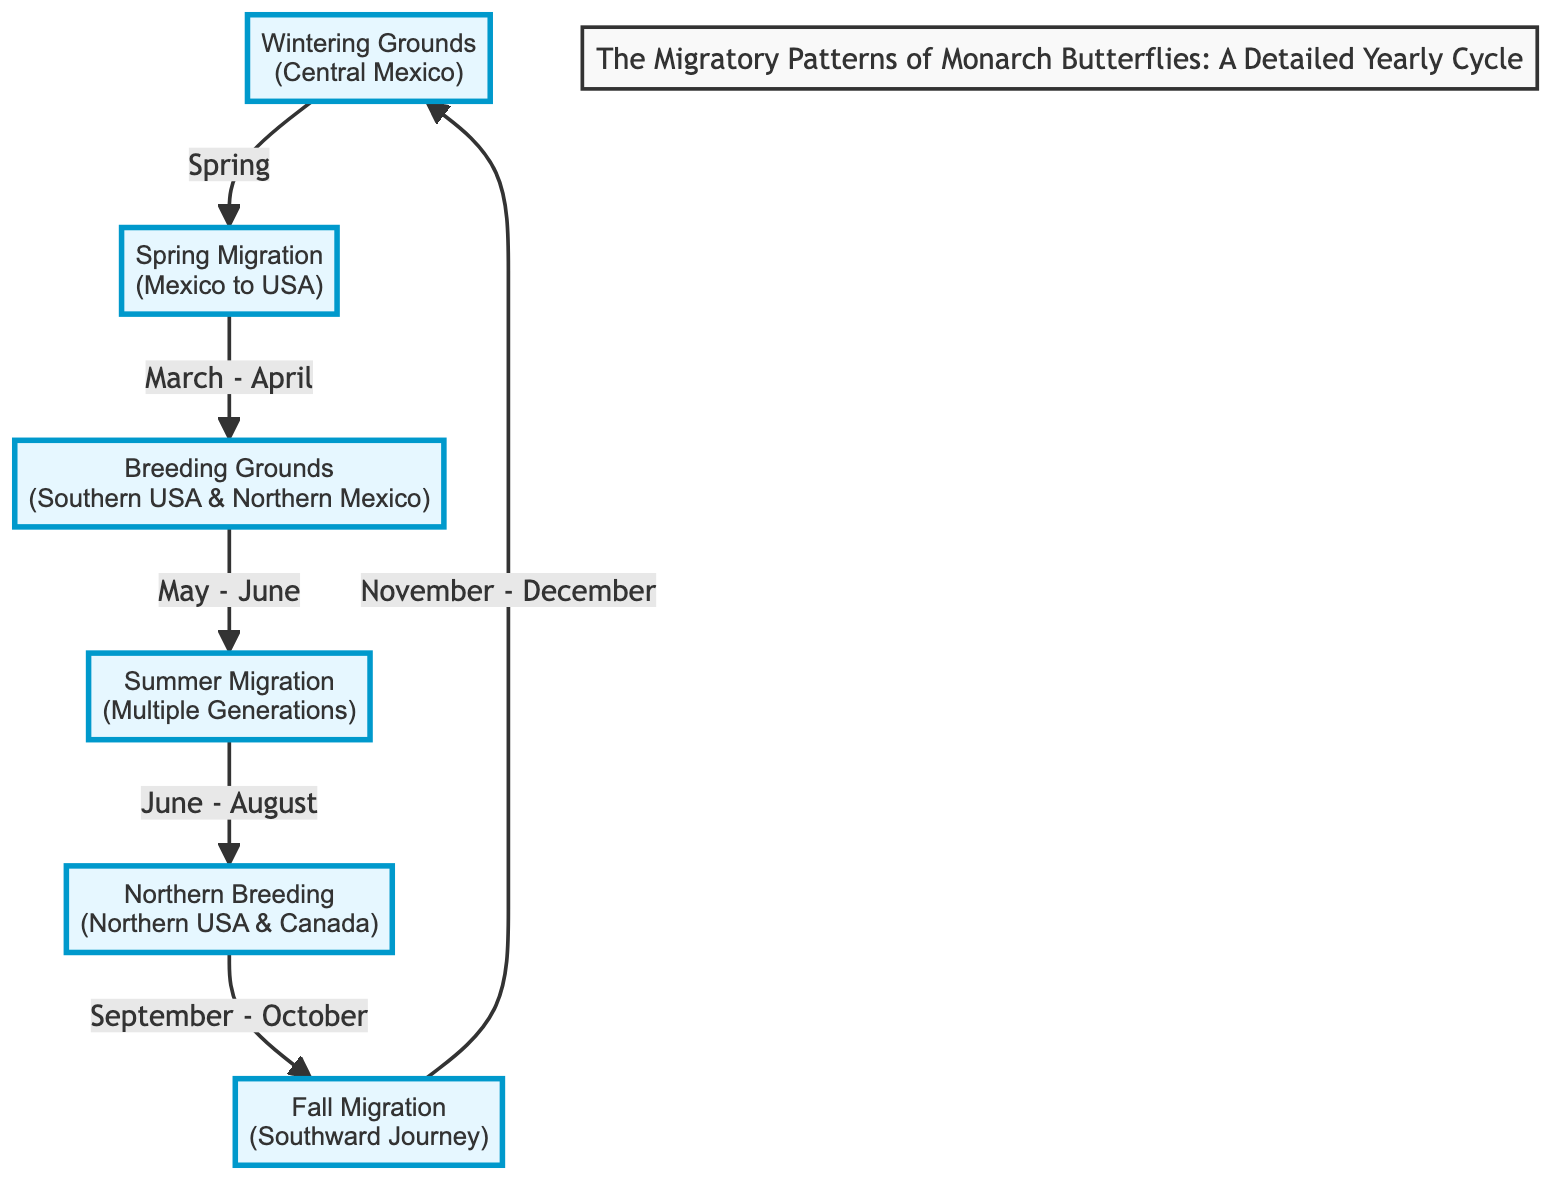What are the Wintering Grounds for Monarch Butterflies? The diagram clearly states that the Wintering Grounds for Monarch Butterflies is located in Central Mexico. This information is presented in the first node of the flowchart.
Answer: Central Mexico What is the first stage in the migratory cycle? According to the diagram, the first stage in the migratory cycle is the Wintering Grounds. This is indicated by the starting point of the flowchart.
Answer: Wintering Grounds In which months do Monarch Butterflies migrate to the Breeding Grounds? The diagram indicates that the migration from Mexico to the Breeding Grounds occurs in March to April. This is explicitly written beside the arrow connecting the Wintering Grounds to the Breeding Grounds.
Answer: March - April How many distinct phases are there in the migratory cycle? The diagram contains 6 different nodes, each representing a distinct phase in the migratory cycle of Monarch Butterflies. This can be counted by examining the different steps in the flowchart.
Answer: 6 What is the endpoint of the Fall Migration? The diagram clearly shows that the endpoint of the Fall Migration leads back to the Wintering Grounds, where the journey concludes before the cycle repeats. This is indicated by the arrow pointing from the Fall Migration to the Wintering Grounds node.
Answer: Wintering Grounds What occurs between May and June in the cycle? According to the diagram, between May and June, the Monarch Butterflies are at the Breeding Grounds. This is specified in the connection from the Breeding Grounds to the next phase in the flowchart.
Answer: Breeding Grounds Which direction do Monarch Butterflies travel during Fall Migration? The diagram indicates that during the Fall Migration, Monarch Butterflies make a southward journey, as shown by the arrows indicating direction from Northern USA and Canada back to Central Mexico.
Answer: Southward What phase follows Summer Migration? The diagram indicates that the phase that follows Summer Migration is Northern Breeding. This is shown by the arrow connecting the two phases in the flowchart, where Summer Migration leads into the Northern Breeding stage.
Answer: Northern Breeding 